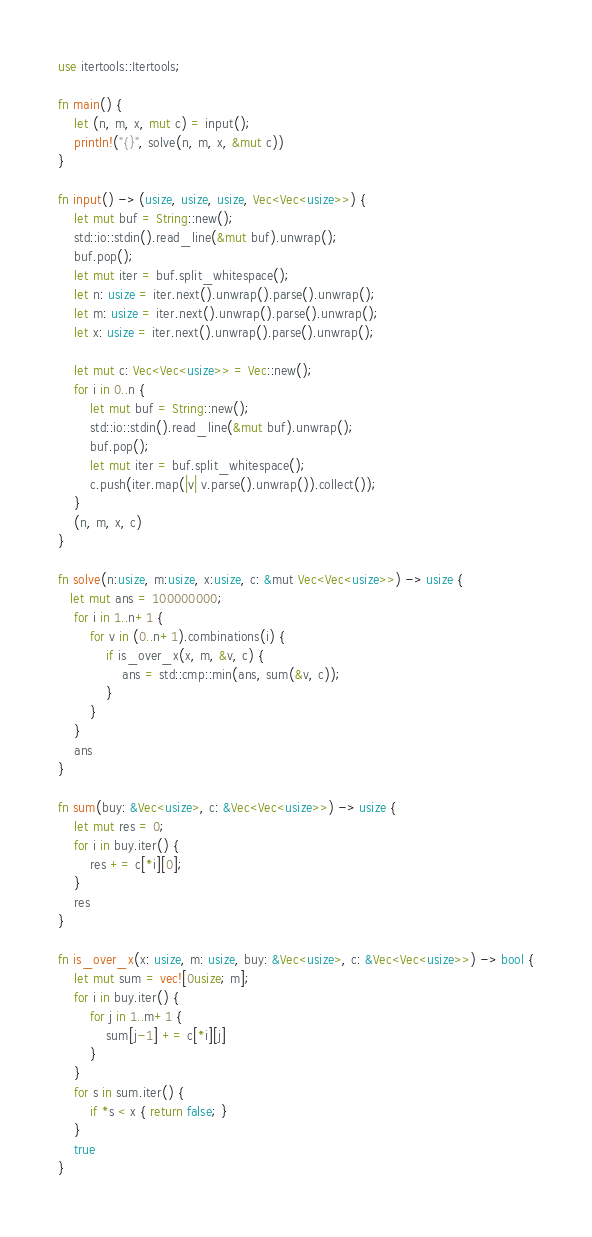Convert code to text. <code><loc_0><loc_0><loc_500><loc_500><_Rust_>use itertools::Itertools;

fn main() {
    let (n, m, x, mut c) = input();
    println!("{}", solve(n, m, x, &mut c))
}

fn input() -> (usize, usize, usize, Vec<Vec<usize>>) {
    let mut buf = String::new();
    std::io::stdin().read_line(&mut buf).unwrap();
    buf.pop();
    let mut iter = buf.split_whitespace();
    let n: usize = iter.next().unwrap().parse().unwrap();
    let m: usize = iter.next().unwrap().parse().unwrap();
    let x: usize = iter.next().unwrap().parse().unwrap();

    let mut c: Vec<Vec<usize>> = Vec::new();
    for i in 0..n {
        let mut buf = String::new();
        std::io::stdin().read_line(&mut buf).unwrap();
        buf.pop();
        let mut iter = buf.split_whitespace();
        c.push(iter.map(|v| v.parse().unwrap()).collect());
    }
    (n, m, x, c)
}

fn solve(n:usize, m:usize, x:usize, c: &mut Vec<Vec<usize>>) -> usize {
   let mut ans = 100000000;
    for i in 1..n+1 {
        for v in (0..n+1).combinations(i) {
            if is_over_x(x, m, &v, c) {
                ans = std::cmp::min(ans, sum(&v, c));
            }
        }
    }
    ans
}

fn sum(buy: &Vec<usize>, c: &Vec<Vec<usize>>) -> usize {
    let mut res = 0;
    for i in buy.iter() {
        res += c[*i][0];
    }
    res
}

fn is_over_x(x: usize, m: usize, buy: &Vec<usize>, c: &Vec<Vec<usize>>) -> bool {
    let mut sum = vec![0usize; m];
    for i in buy.iter() {
        for j in 1..m+1 {
            sum[j-1] += c[*i][j]
        }
    }
    for s in sum.iter() {
        if *s < x { return false; }
    }
    true
}</code> 